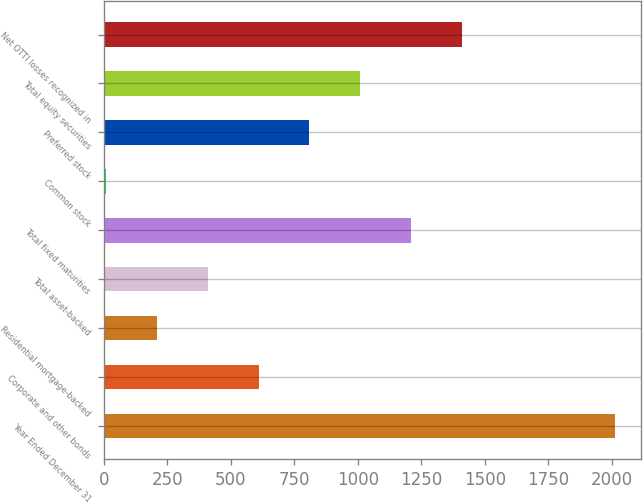Convert chart. <chart><loc_0><loc_0><loc_500><loc_500><bar_chart><fcel>Year Ended December 31<fcel>Corporate and other bonds<fcel>Residential mortgage-backed<fcel>Total asset-backed<fcel>Total fixed maturities<fcel>Common stock<fcel>Preferred stock<fcel>Total equity securities<fcel>Net OTTI losses recognized in<nl><fcel>2013<fcel>609.5<fcel>208.5<fcel>409<fcel>1211<fcel>8<fcel>810<fcel>1010.5<fcel>1411.5<nl></chart> 